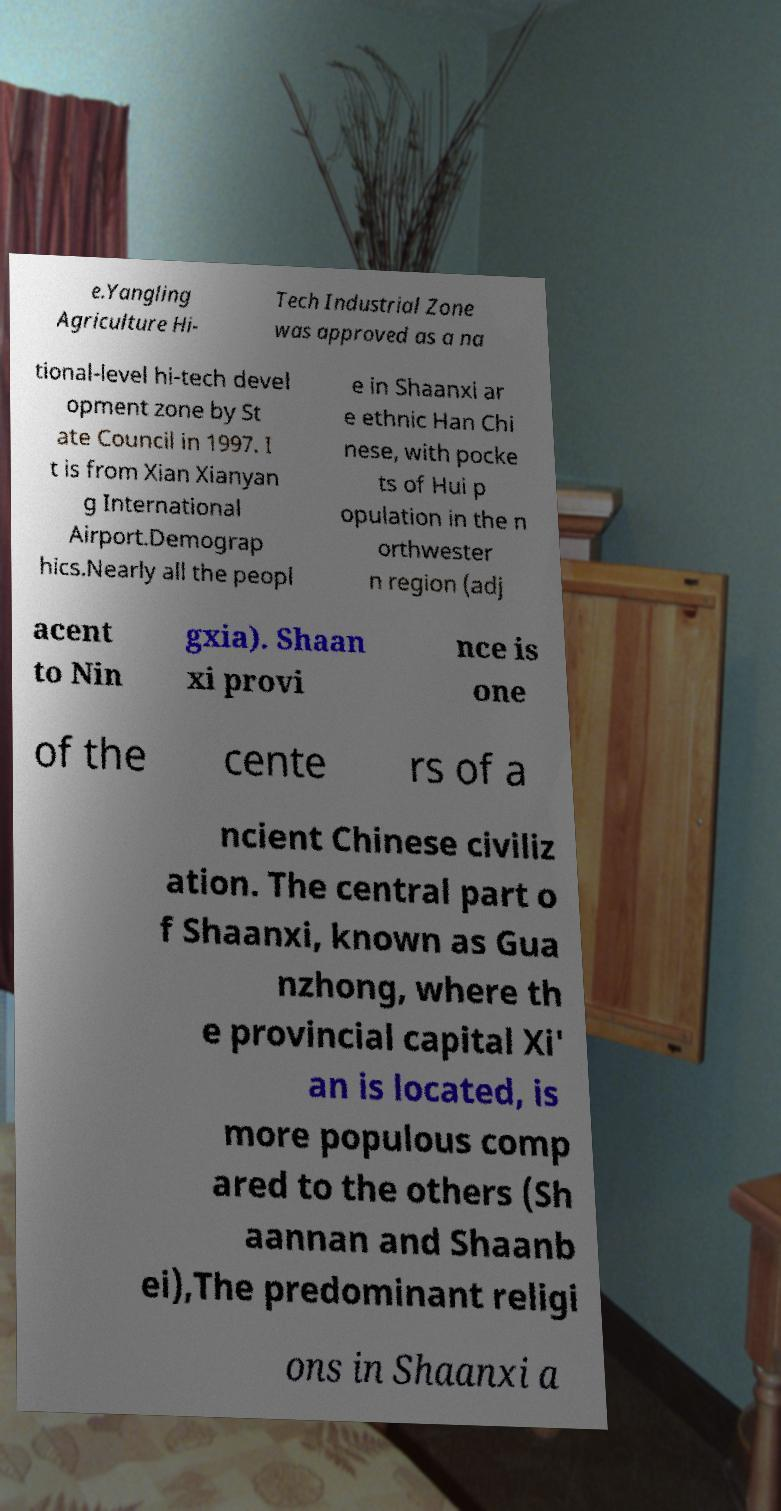Could you extract and type out the text from this image? e.Yangling Agriculture Hi- Tech Industrial Zone was approved as a na tional-level hi-tech devel opment zone by St ate Council in 1997. I t is from Xian Xianyan g International Airport.Demograp hics.Nearly all the peopl e in Shaanxi ar e ethnic Han Chi nese, with pocke ts of Hui p opulation in the n orthwester n region (adj acent to Nin gxia). Shaan xi provi nce is one of the cente rs of a ncient Chinese civiliz ation. The central part o f Shaanxi, known as Gua nzhong, where th e provincial capital Xi' an is located, is more populous comp ared to the others (Sh aannan and Shaanb ei),The predominant religi ons in Shaanxi a 